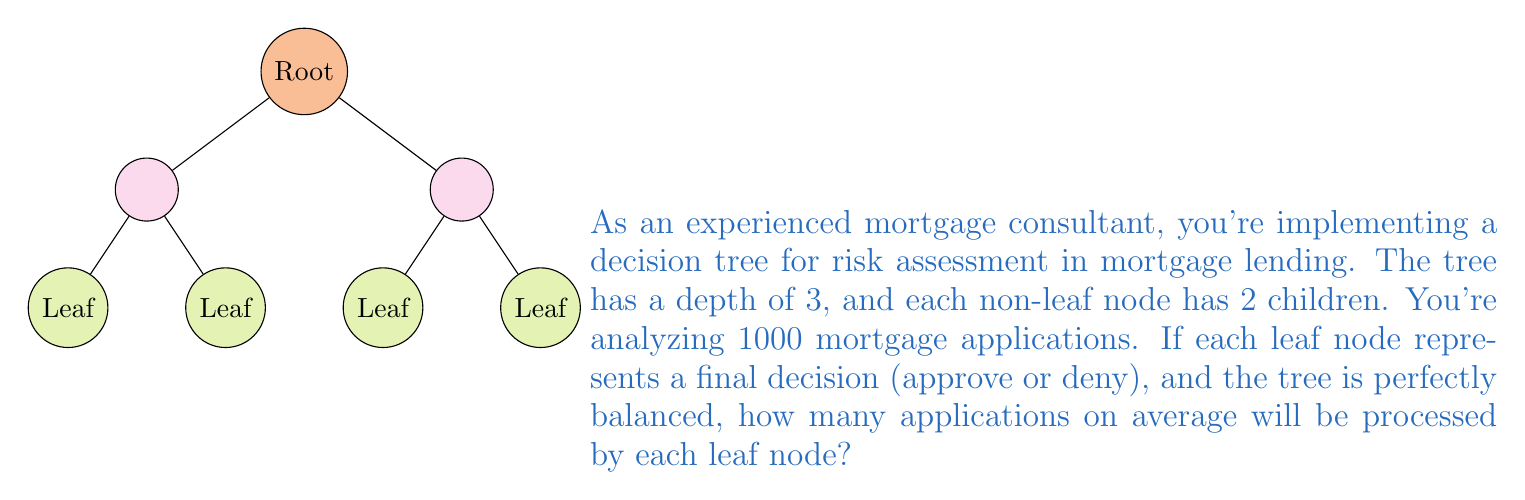Help me with this question. Let's approach this step-by-step:

1) First, we need to calculate the number of leaf nodes in the decision tree.
   - The tree has a depth of 3
   - Each non-leaf node has 2 children
   - This forms a perfect binary tree of depth 3

2) In a perfect binary tree, the number of leaf nodes is given by $2^d$, where $d$ is the depth of the tree.
   Number of leaf nodes = $2^3 = 8$

3) Now, we know:
   - Total number of applications = 1000
   - Number of leaf nodes = 8

4) To find the average number of applications processed by each leaf node, we divide the total number of applications by the number of leaf nodes:

   $$\text{Average applications per leaf} = \frac{\text{Total applications}}{\text{Number of leaf nodes}} = \frac{1000}{8} = 125$$

Therefore, on average, each leaf node will process 125 applications.
Answer: 125 applications 